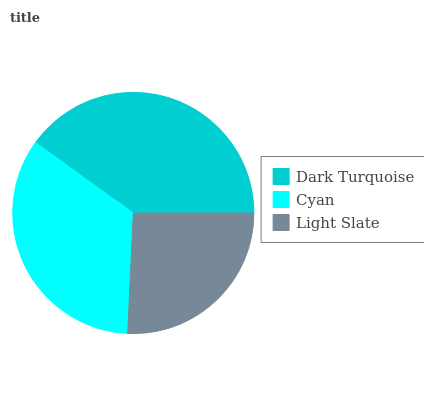Is Light Slate the minimum?
Answer yes or no. Yes. Is Dark Turquoise the maximum?
Answer yes or no. Yes. Is Cyan the minimum?
Answer yes or no. No. Is Cyan the maximum?
Answer yes or no. No. Is Dark Turquoise greater than Cyan?
Answer yes or no. Yes. Is Cyan less than Dark Turquoise?
Answer yes or no. Yes. Is Cyan greater than Dark Turquoise?
Answer yes or no. No. Is Dark Turquoise less than Cyan?
Answer yes or no. No. Is Cyan the high median?
Answer yes or no. Yes. Is Cyan the low median?
Answer yes or no. Yes. Is Dark Turquoise the high median?
Answer yes or no. No. Is Dark Turquoise the low median?
Answer yes or no. No. 